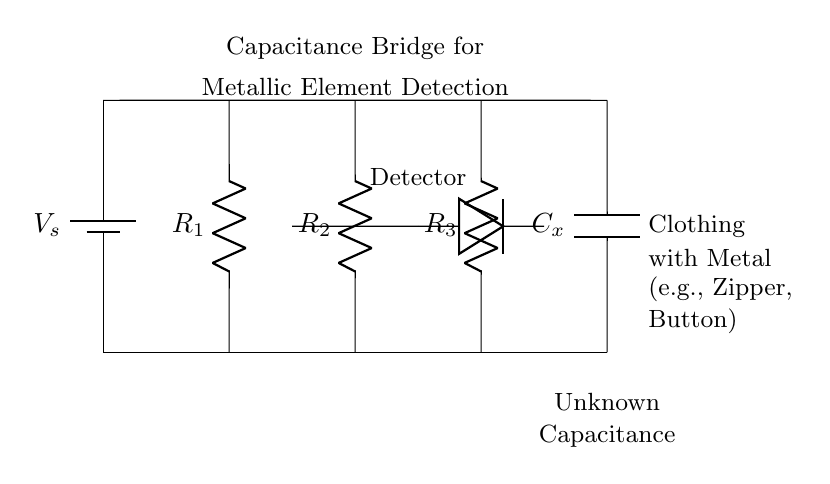What type of bridge is depicted in the circuit? The circuit is a capacitance bridge, which is specifically used for measuring unknown capacitance values. It connects a known voltage source and uses resistors and a capacitor to balance the circuit.
Answer: capacitance bridge What component is indicated as the detector? The detector in the circuit is represented by a diode label, which is typically used to signal when there is a change in the circuit, indicating the presence of a metallic element.
Answer: diode How many resistors are present in the circuit? The circuit diagram shows three resistors labeled as R1, R2, and R3. Each one serves to balance the bridge circuit.
Answer: three What is the purpose of the capacitor labeled Cx? The capacitor labeled Cx is the unknown capacitance that the circuit aims to measure, usually corresponding to metallic elements in clothing items.
Answer: measure metal What type of clothing items is this circuit designed to detect metallic elements in? The circuit is designed to detect metallic elements in clothing items, specifically zippers and buttons, as indicated in the diagram.
Answer: zippers and buttons What does the voltage source labeled V_s indicate? The voltage source V_s indicates the supplied voltage for the circuit, which powers the capacitance bridge. It sets the potential difference necessary for the detection mechanism.
Answer: power supply 